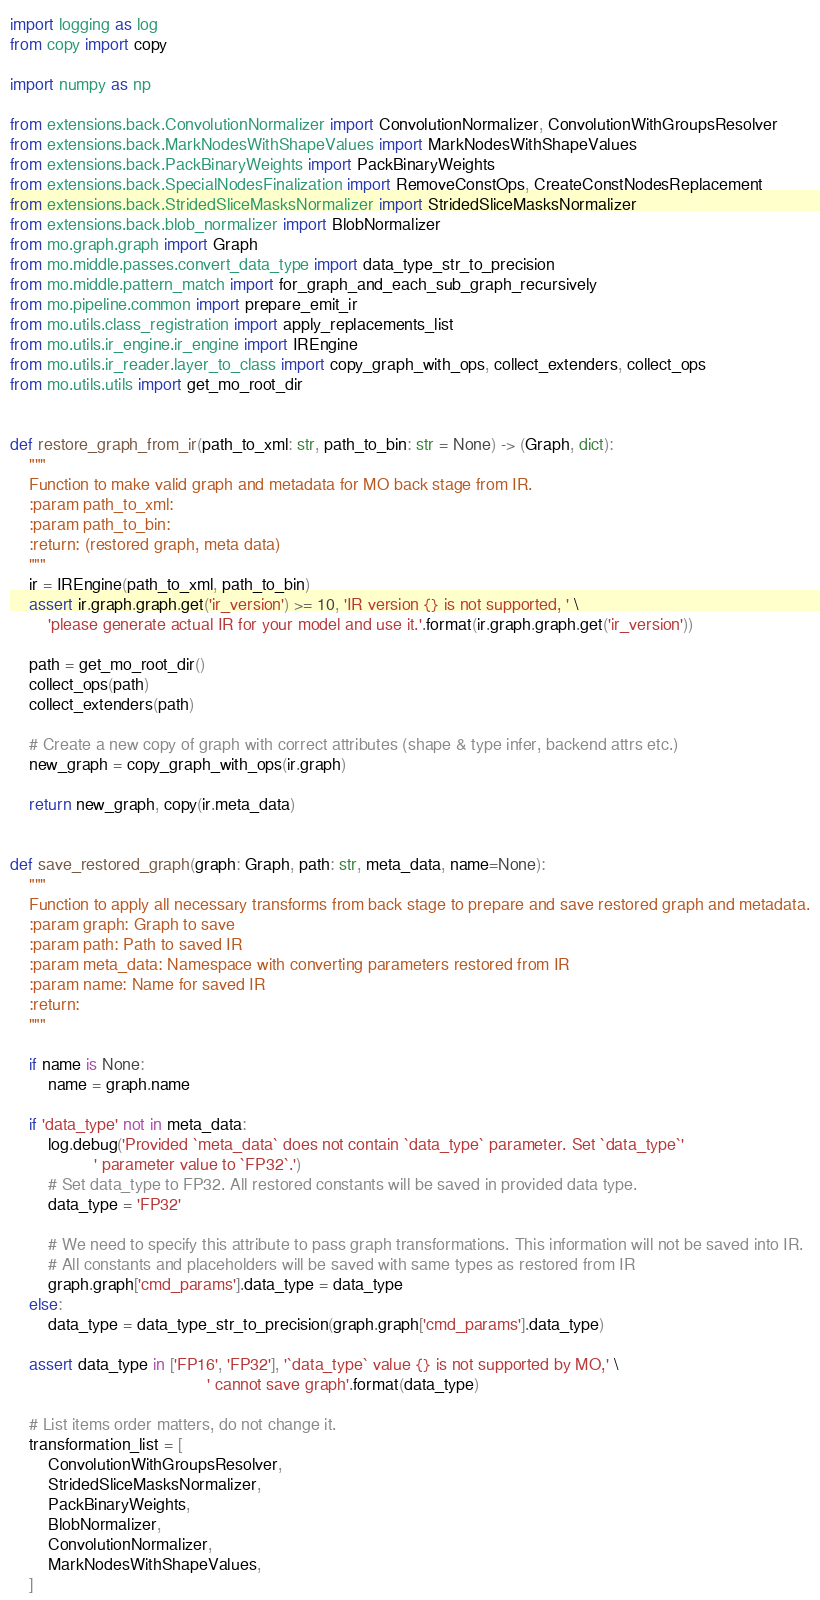Convert code to text. <code><loc_0><loc_0><loc_500><loc_500><_Python_>import logging as log
from copy import copy

import numpy as np

from extensions.back.ConvolutionNormalizer import ConvolutionNormalizer, ConvolutionWithGroupsResolver
from extensions.back.MarkNodesWithShapeValues import MarkNodesWithShapeValues
from extensions.back.PackBinaryWeights import PackBinaryWeights
from extensions.back.SpecialNodesFinalization import RemoveConstOps, CreateConstNodesReplacement
from extensions.back.StridedSliceMasksNormalizer import StridedSliceMasksNormalizer
from extensions.back.blob_normalizer import BlobNormalizer
from mo.graph.graph import Graph
from mo.middle.passes.convert_data_type import data_type_str_to_precision
from mo.middle.pattern_match import for_graph_and_each_sub_graph_recursively
from mo.pipeline.common import prepare_emit_ir
from mo.utils.class_registration import apply_replacements_list
from mo.utils.ir_engine.ir_engine import IREngine
from mo.utils.ir_reader.layer_to_class import copy_graph_with_ops, collect_extenders, collect_ops
from mo.utils.utils import get_mo_root_dir


def restore_graph_from_ir(path_to_xml: str, path_to_bin: str = None) -> (Graph, dict):
    """
    Function to make valid graph and metadata for MO back stage from IR.
    :param path_to_xml:
    :param path_to_bin:
    :return: (restored graph, meta data)
    """
    ir = IREngine(path_to_xml, path_to_bin)
    assert ir.graph.graph.get('ir_version') >= 10, 'IR version {} is not supported, ' \
        'please generate actual IR for your model and use it.'.format(ir.graph.graph.get('ir_version'))

    path = get_mo_root_dir()
    collect_ops(path)
    collect_extenders(path)

    # Create a new copy of graph with correct attributes (shape & type infer, backend attrs etc.)
    new_graph = copy_graph_with_ops(ir.graph)

    return new_graph, copy(ir.meta_data)


def save_restored_graph(graph: Graph, path: str, meta_data, name=None):
    """
    Function to apply all necessary transforms from back stage to prepare and save restored graph and metadata.
    :param graph: Graph to save
    :param path: Path to saved IR
    :param meta_data: Namespace with converting parameters restored from IR
    :param name: Name for saved IR
    :return:
    """

    if name is None:
        name = graph.name

    if 'data_type' not in meta_data:
        log.debug('Provided `meta_data` does not contain `data_type` parameter. Set `data_type`'
                  ' parameter value to `FP32`.')
        # Set data_type to FP32. All restored constants will be saved in provided data type.
        data_type = 'FP32'

        # We need to specify this attribute to pass graph transformations. This information will not be saved into IR.
        # All constants and placeholders will be saved with same types as restored from IR
        graph.graph['cmd_params'].data_type = data_type
    else:
        data_type = data_type_str_to_precision(graph.graph['cmd_params'].data_type)

    assert data_type in ['FP16', 'FP32'], '`data_type` value {} is not supported by MO,' \
                                          ' cannot save graph'.format(data_type)

    # List items order matters, do not change it.
    transformation_list = [
        ConvolutionWithGroupsResolver,
        StridedSliceMasksNormalizer,
        PackBinaryWeights,
        BlobNormalizer,
        ConvolutionNormalizer,
        MarkNodesWithShapeValues,
    ]
</code> 